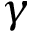<formula> <loc_0><loc_0><loc_500><loc_500>\gamma</formula> 